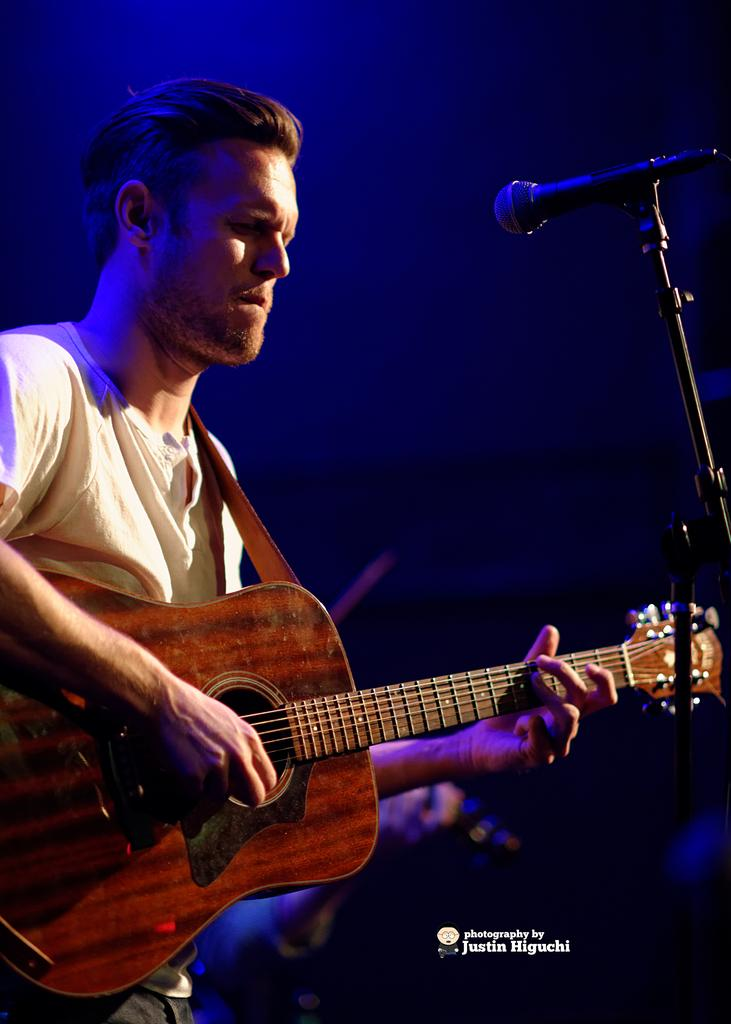What is the person in the image doing? The person is playing a guitar. What object is in front of the person? There is a microphone in front of the person. Is there any support for the microphone? Yes, there is a microphone stand associated with the microphone. What type of rice can be seen in the person's hand in the image? There is no rice present in the image; the person is playing a guitar and there is a microphone in front of them. 